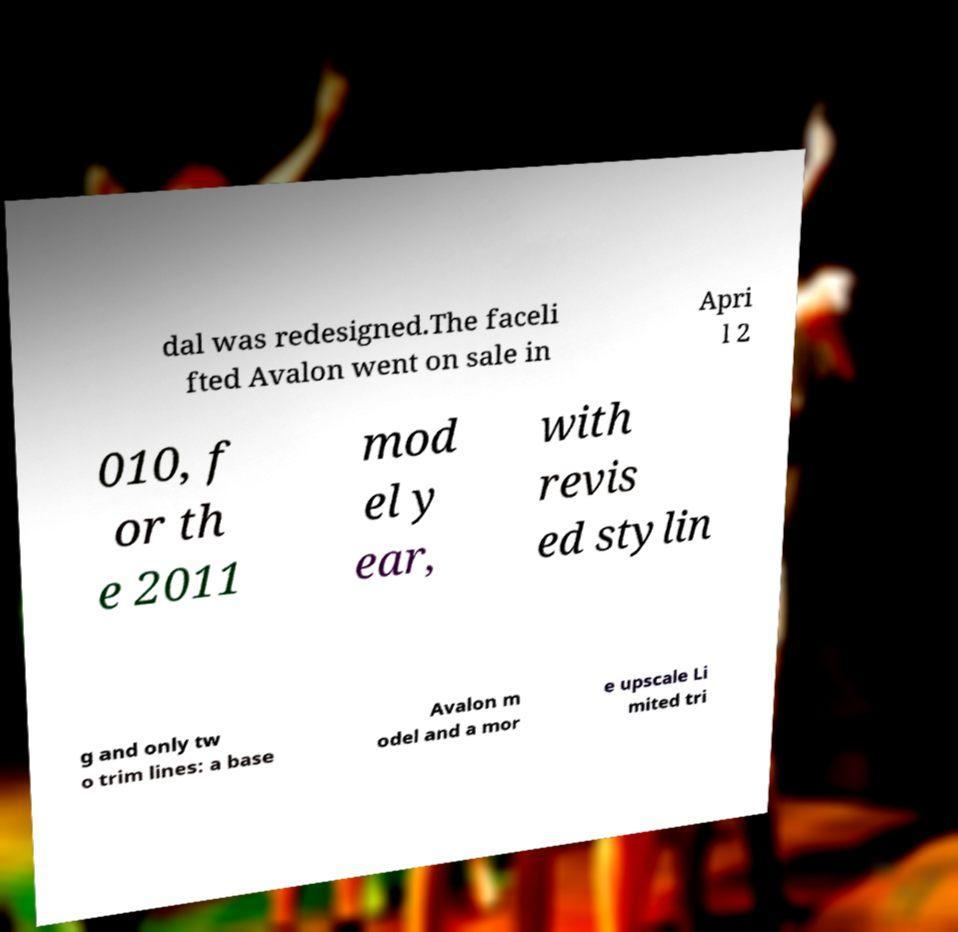Please read and relay the text visible in this image. What does it say? dal was redesigned.The faceli fted Avalon went on sale in Apri l 2 010, f or th e 2011 mod el y ear, with revis ed stylin g and only tw o trim lines: a base Avalon m odel and a mor e upscale Li mited tri 